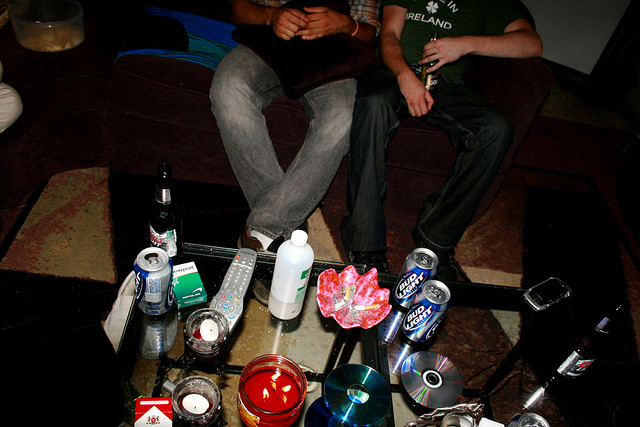Read all the text in this image. RELAND BUD LIGHT LIGHT IN 